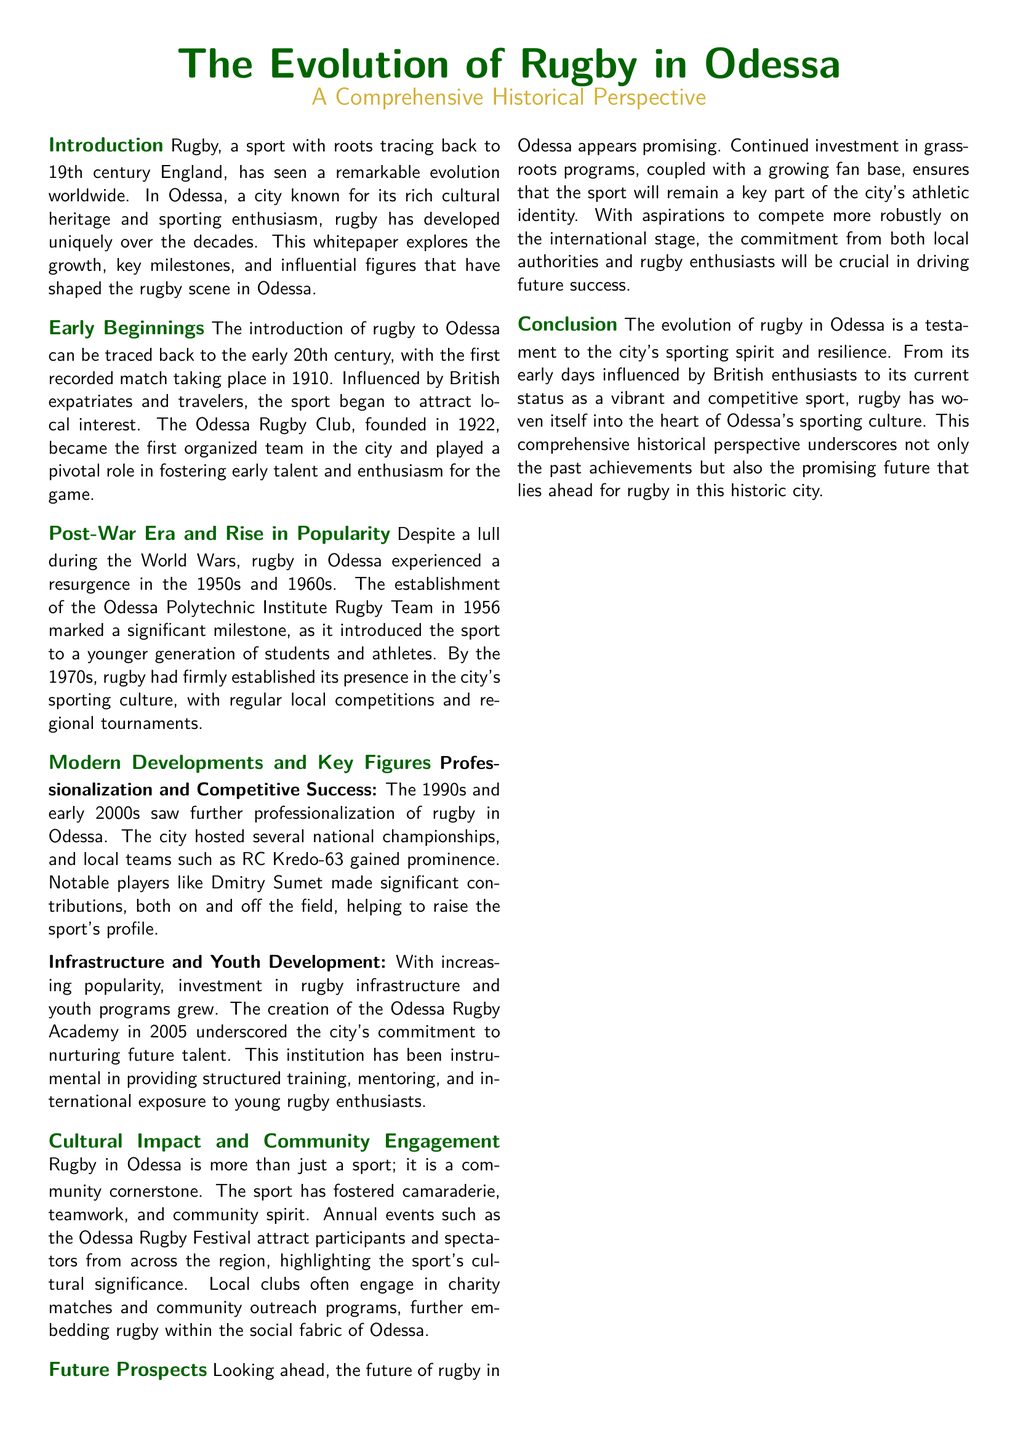what year did the first recorded rugby match take place in Odessa? The document states that the first recorded match took place in 1910.
Answer: 1910 who founded the Odessa Rugby Club? It was founded in 1922.
Answer: 1922 what significant event for rugby in Odessa occurred in 1956? The establishment of the Odessa Polytechnic Institute Rugby Team marked a significant milestone.
Answer: Establishment of the Odessa Polytechnic Institute Rugby Team what is the name of the notable player mentioned in the document? Dmitry Sumet is highlighted as a notable player.
Answer: Dmitry Sumet when was the Odessa Rugby Academy created? The Odessa Rugby Academy was created in 2005.
Answer: 2005 what types of community events does rugby in Odessa engage with? Local clubs engage in charity matches and community outreach programs.
Answer: Charity matches and community outreach programs what is the cultural significance of the Odessa Rugby Festival? The festival attracts participants and spectators from across the region, highlighting the sport's cultural significance.
Answer: Cultural significance what future prospects are mentioned for rugby in Odessa? The document mentions continued investment in grassroots programs and a growing fan base as future prospects.
Answer: Continued investment in grassroots programs how has rugby impacted the community in Odessa? Rugby has fostered camaraderie, teamwork, and community spirit within the city.
Answer: Camaraderie, teamwork, and community spirit 